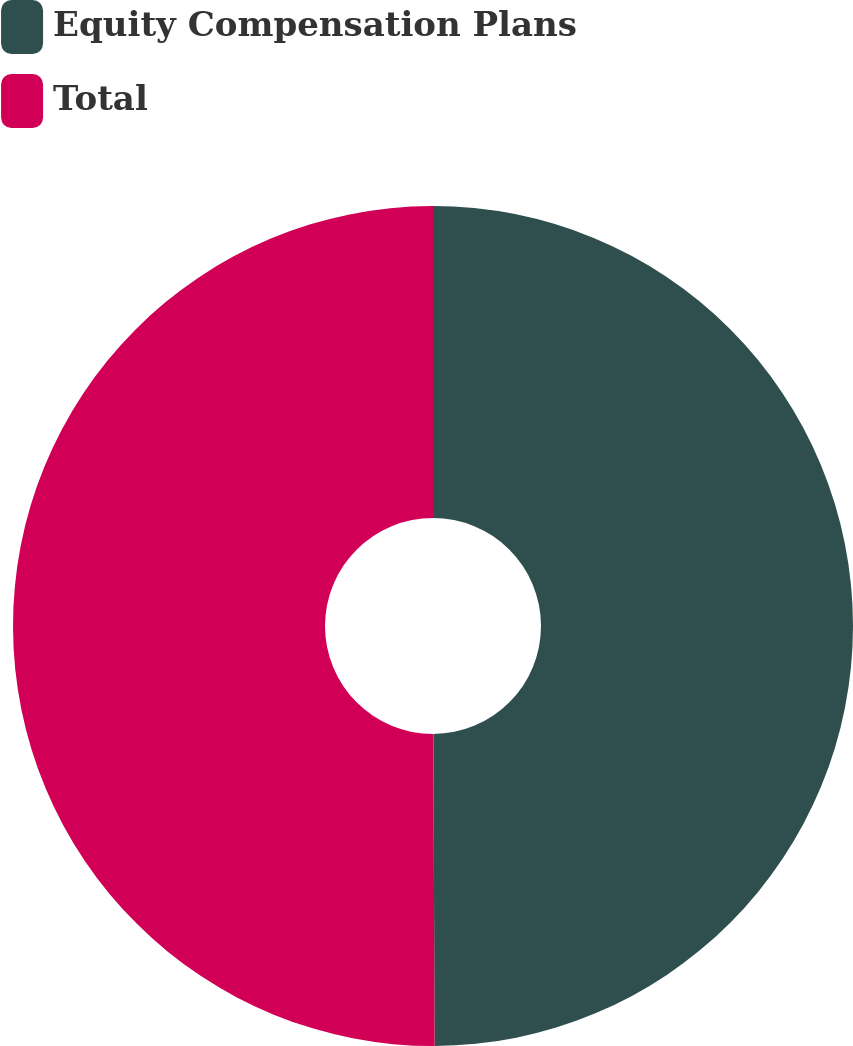Convert chart. <chart><loc_0><loc_0><loc_500><loc_500><pie_chart><fcel>Equity Compensation Plans<fcel>Total<nl><fcel>49.94%<fcel>50.06%<nl></chart> 